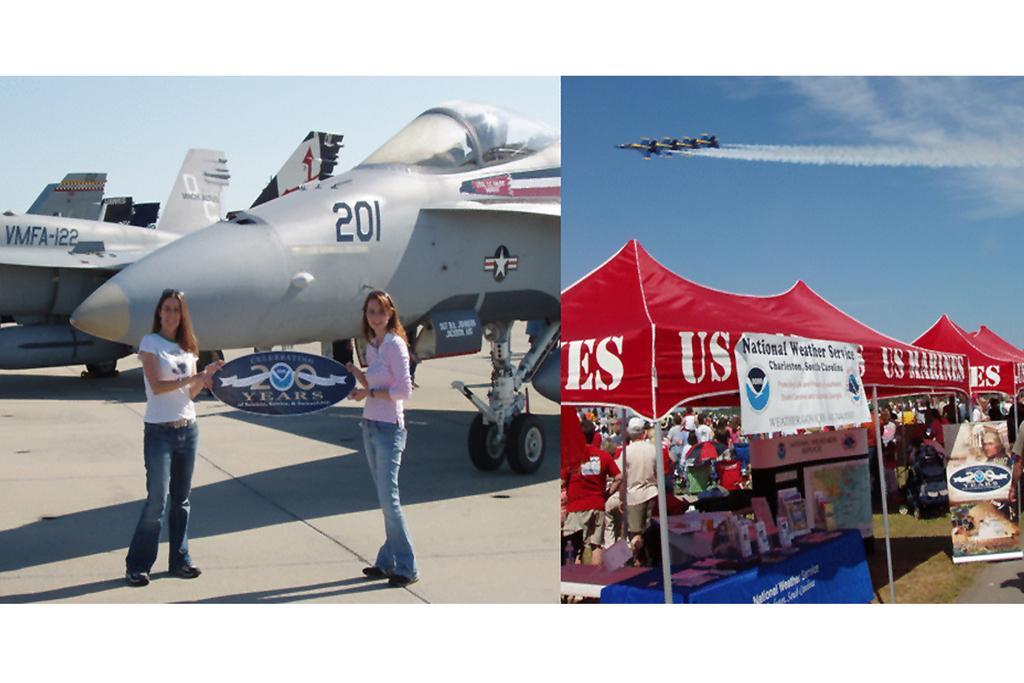Can you describe this image briefly? This is a collage image. Here I can see two pictures. In the right side picture, I can see few objects are placed under the red color tent. In the background few people are standing. On the top of this image I can see few aeroplanes are flying in the air towards the left side. In the left side image I can see two planes on the lang and two women are standing, smiling and giving pose for the picture. On the top of this image I can see the sky. 